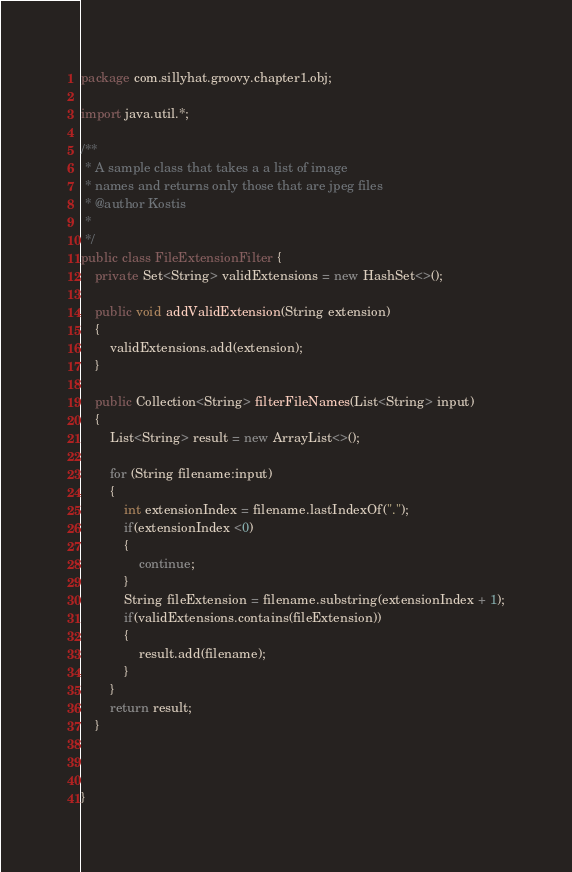<code> <loc_0><loc_0><loc_500><loc_500><_Java_>package com.sillyhat.groovy.chapter1.obj;

import java.util.*;

/**
 * A sample class that takes a a list of image 
 * names and returns only those that are jpeg files
 * @author Kostis
 *
 */
public class FileExtensionFilter {
	private Set<String> validExtensions = new HashSet<>();
	
	public void addValidExtension(String extension)
	{
		validExtensions.add(extension);
	}
	
	public Collection<String> filterFileNames(List<String> input)
	{
		List<String> result = new ArrayList<>();
		
		for (String filename:input)
		{
			int extensionIndex = filename.lastIndexOf(".");
			if(extensionIndex <0)
			{
				continue;
			}
		    String fileExtension = filename.substring(extensionIndex + 1);
		    if(validExtensions.contains(fileExtension))
		    {
		    	result.add(filename);
		    }
		}
		return result;
	}
	
	

}
</code> 